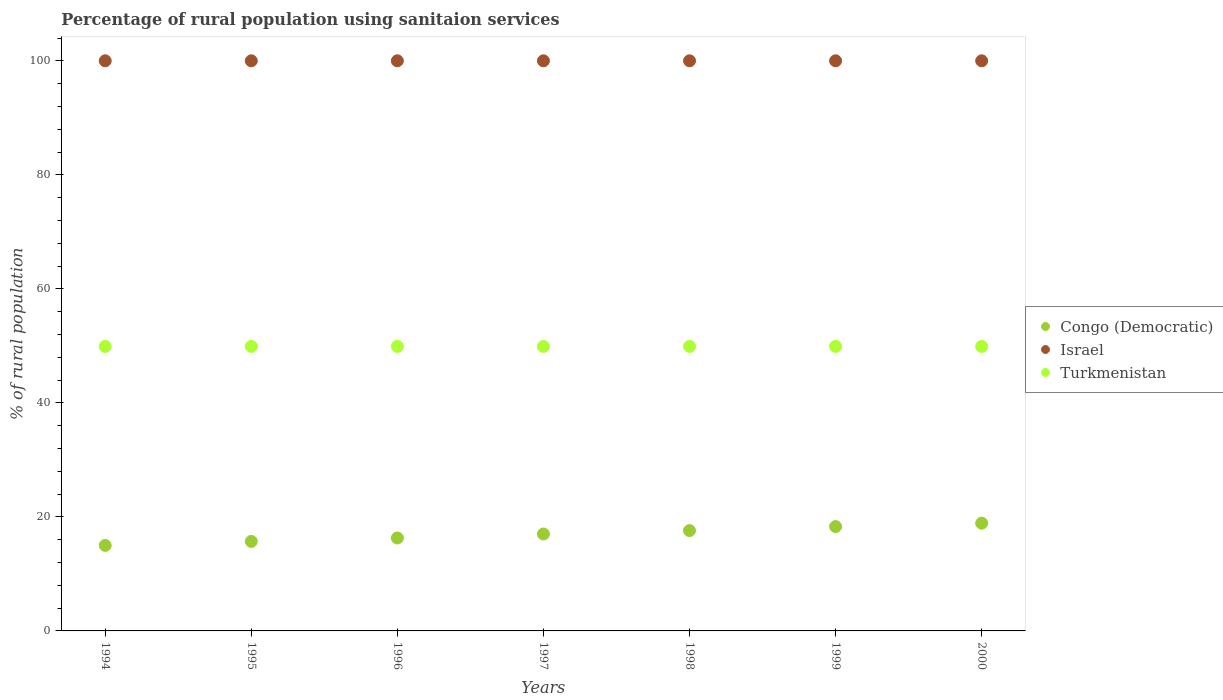How many different coloured dotlines are there?
Your answer should be compact. 3. Is the number of dotlines equal to the number of legend labels?
Your answer should be compact. Yes. What is the percentage of rural population using sanitaion services in Israel in 1994?
Your response must be concise. 100. Across all years, what is the maximum percentage of rural population using sanitaion services in Turkmenistan?
Your answer should be compact. 49.9. Across all years, what is the minimum percentage of rural population using sanitaion services in Turkmenistan?
Your answer should be very brief. 49.9. What is the total percentage of rural population using sanitaion services in Israel in the graph?
Your answer should be very brief. 700. What is the difference between the percentage of rural population using sanitaion services in Israel in 1994 and the percentage of rural population using sanitaion services in Congo (Democratic) in 1995?
Your answer should be compact. 84.3. What is the average percentage of rural population using sanitaion services in Turkmenistan per year?
Your answer should be compact. 49.9. In the year 1995, what is the difference between the percentage of rural population using sanitaion services in Israel and percentage of rural population using sanitaion services in Congo (Democratic)?
Give a very brief answer. 84.3. In how many years, is the percentage of rural population using sanitaion services in Israel greater than 28 %?
Offer a terse response. 7. What is the ratio of the percentage of rural population using sanitaion services in Turkmenistan in 1997 to that in 2000?
Provide a short and direct response. 1. Is the percentage of rural population using sanitaion services in Turkmenistan in 1995 less than that in 1999?
Offer a terse response. No. What is the difference between the highest and the second highest percentage of rural population using sanitaion services in Turkmenistan?
Your answer should be very brief. 0. What is the difference between the highest and the lowest percentage of rural population using sanitaion services in Turkmenistan?
Offer a very short reply. 0. In how many years, is the percentage of rural population using sanitaion services in Congo (Democratic) greater than the average percentage of rural population using sanitaion services in Congo (Democratic) taken over all years?
Give a very brief answer. 4. Is the percentage of rural population using sanitaion services in Congo (Democratic) strictly greater than the percentage of rural population using sanitaion services in Israel over the years?
Provide a short and direct response. No. Are the values on the major ticks of Y-axis written in scientific E-notation?
Your answer should be very brief. No. Does the graph contain any zero values?
Provide a succinct answer. No. How are the legend labels stacked?
Make the answer very short. Vertical. What is the title of the graph?
Ensure brevity in your answer.  Percentage of rural population using sanitaion services. What is the label or title of the Y-axis?
Make the answer very short. % of rural population. What is the % of rural population in Turkmenistan in 1994?
Your answer should be compact. 49.9. What is the % of rural population of Turkmenistan in 1995?
Your answer should be compact. 49.9. What is the % of rural population of Turkmenistan in 1996?
Give a very brief answer. 49.9. What is the % of rural population in Congo (Democratic) in 1997?
Provide a short and direct response. 17. What is the % of rural population of Turkmenistan in 1997?
Provide a short and direct response. 49.9. What is the % of rural population in Congo (Democratic) in 1998?
Your answer should be very brief. 17.6. What is the % of rural population of Israel in 1998?
Give a very brief answer. 100. What is the % of rural population of Turkmenistan in 1998?
Your answer should be compact. 49.9. What is the % of rural population of Congo (Democratic) in 1999?
Provide a succinct answer. 18.3. What is the % of rural population of Turkmenistan in 1999?
Provide a succinct answer. 49.9. What is the % of rural population in Congo (Democratic) in 2000?
Your response must be concise. 18.9. What is the % of rural population of Israel in 2000?
Provide a succinct answer. 100. What is the % of rural population in Turkmenistan in 2000?
Ensure brevity in your answer.  49.9. Across all years, what is the maximum % of rural population in Congo (Democratic)?
Your answer should be compact. 18.9. Across all years, what is the maximum % of rural population in Turkmenistan?
Make the answer very short. 49.9. Across all years, what is the minimum % of rural population in Congo (Democratic)?
Make the answer very short. 15. Across all years, what is the minimum % of rural population of Turkmenistan?
Your answer should be compact. 49.9. What is the total % of rural population in Congo (Democratic) in the graph?
Provide a short and direct response. 118.8. What is the total % of rural population of Israel in the graph?
Keep it short and to the point. 700. What is the total % of rural population in Turkmenistan in the graph?
Offer a very short reply. 349.3. What is the difference between the % of rural population in Congo (Democratic) in 1994 and that in 1995?
Keep it short and to the point. -0.7. What is the difference between the % of rural population in Congo (Democratic) in 1994 and that in 1996?
Offer a very short reply. -1.3. What is the difference between the % of rural population in Israel in 1994 and that in 1996?
Make the answer very short. 0. What is the difference between the % of rural population of Turkmenistan in 1994 and that in 1996?
Your response must be concise. 0. What is the difference between the % of rural population in Turkmenistan in 1994 and that in 1997?
Provide a short and direct response. 0. What is the difference between the % of rural population in Congo (Democratic) in 1994 and that in 1998?
Your answer should be very brief. -2.6. What is the difference between the % of rural population in Israel in 1994 and that in 1998?
Your answer should be compact. 0. What is the difference between the % of rural population of Turkmenistan in 1994 and that in 1998?
Your answer should be very brief. 0. What is the difference between the % of rural population of Congo (Democratic) in 1994 and that in 1999?
Ensure brevity in your answer.  -3.3. What is the difference between the % of rural population of Israel in 1994 and that in 1999?
Offer a terse response. 0. What is the difference between the % of rural population of Congo (Democratic) in 1994 and that in 2000?
Ensure brevity in your answer.  -3.9. What is the difference between the % of rural population in Israel in 1994 and that in 2000?
Give a very brief answer. 0. What is the difference between the % of rural population of Turkmenistan in 1994 and that in 2000?
Keep it short and to the point. 0. What is the difference between the % of rural population in Congo (Democratic) in 1995 and that in 1996?
Your answer should be compact. -0.6. What is the difference between the % of rural population in Israel in 1995 and that in 1996?
Your answer should be compact. 0. What is the difference between the % of rural population of Congo (Democratic) in 1995 and that in 1997?
Give a very brief answer. -1.3. What is the difference between the % of rural population in Turkmenistan in 1995 and that in 1997?
Keep it short and to the point. 0. What is the difference between the % of rural population in Congo (Democratic) in 1995 and that in 1998?
Provide a short and direct response. -1.9. What is the difference between the % of rural population in Turkmenistan in 1995 and that in 1998?
Ensure brevity in your answer.  0. What is the difference between the % of rural population in Congo (Democratic) in 1995 and that in 1999?
Your answer should be very brief. -2.6. What is the difference between the % of rural population of Congo (Democratic) in 1995 and that in 2000?
Your response must be concise. -3.2. What is the difference between the % of rural population of Congo (Democratic) in 1996 and that in 1997?
Ensure brevity in your answer.  -0.7. What is the difference between the % of rural population of Israel in 1996 and that in 1997?
Your response must be concise. 0. What is the difference between the % of rural population of Turkmenistan in 1996 and that in 1998?
Your response must be concise. 0. What is the difference between the % of rural population of Congo (Democratic) in 1996 and that in 1999?
Ensure brevity in your answer.  -2. What is the difference between the % of rural population in Congo (Democratic) in 1996 and that in 2000?
Give a very brief answer. -2.6. What is the difference between the % of rural population of Israel in 1996 and that in 2000?
Your answer should be compact. 0. What is the difference between the % of rural population in Congo (Democratic) in 1997 and that in 1998?
Give a very brief answer. -0.6. What is the difference between the % of rural population of Congo (Democratic) in 1997 and that in 1999?
Offer a very short reply. -1.3. What is the difference between the % of rural population in Turkmenistan in 1997 and that in 1999?
Give a very brief answer. 0. What is the difference between the % of rural population of Congo (Democratic) in 1997 and that in 2000?
Ensure brevity in your answer.  -1.9. What is the difference between the % of rural population in Turkmenistan in 1998 and that in 1999?
Your answer should be compact. 0. What is the difference between the % of rural population of Israel in 1998 and that in 2000?
Give a very brief answer. 0. What is the difference between the % of rural population in Israel in 1999 and that in 2000?
Your answer should be compact. 0. What is the difference between the % of rural population of Congo (Democratic) in 1994 and the % of rural population of Israel in 1995?
Keep it short and to the point. -85. What is the difference between the % of rural population of Congo (Democratic) in 1994 and the % of rural population of Turkmenistan in 1995?
Make the answer very short. -34.9. What is the difference between the % of rural population of Israel in 1994 and the % of rural population of Turkmenistan in 1995?
Your response must be concise. 50.1. What is the difference between the % of rural population in Congo (Democratic) in 1994 and the % of rural population in Israel in 1996?
Provide a short and direct response. -85. What is the difference between the % of rural population of Congo (Democratic) in 1994 and the % of rural population of Turkmenistan in 1996?
Keep it short and to the point. -34.9. What is the difference between the % of rural population in Israel in 1994 and the % of rural population in Turkmenistan in 1996?
Your answer should be very brief. 50.1. What is the difference between the % of rural population of Congo (Democratic) in 1994 and the % of rural population of Israel in 1997?
Your answer should be compact. -85. What is the difference between the % of rural population in Congo (Democratic) in 1994 and the % of rural population in Turkmenistan in 1997?
Offer a very short reply. -34.9. What is the difference between the % of rural population in Israel in 1994 and the % of rural population in Turkmenistan in 1997?
Your answer should be very brief. 50.1. What is the difference between the % of rural population of Congo (Democratic) in 1994 and the % of rural population of Israel in 1998?
Provide a succinct answer. -85. What is the difference between the % of rural population of Congo (Democratic) in 1994 and the % of rural population of Turkmenistan in 1998?
Offer a very short reply. -34.9. What is the difference between the % of rural population in Israel in 1994 and the % of rural population in Turkmenistan in 1998?
Your answer should be very brief. 50.1. What is the difference between the % of rural population of Congo (Democratic) in 1994 and the % of rural population of Israel in 1999?
Make the answer very short. -85. What is the difference between the % of rural population of Congo (Democratic) in 1994 and the % of rural population of Turkmenistan in 1999?
Keep it short and to the point. -34.9. What is the difference between the % of rural population of Israel in 1994 and the % of rural population of Turkmenistan in 1999?
Provide a short and direct response. 50.1. What is the difference between the % of rural population of Congo (Democratic) in 1994 and the % of rural population of Israel in 2000?
Offer a terse response. -85. What is the difference between the % of rural population in Congo (Democratic) in 1994 and the % of rural population in Turkmenistan in 2000?
Give a very brief answer. -34.9. What is the difference between the % of rural population in Israel in 1994 and the % of rural population in Turkmenistan in 2000?
Give a very brief answer. 50.1. What is the difference between the % of rural population in Congo (Democratic) in 1995 and the % of rural population in Israel in 1996?
Provide a succinct answer. -84.3. What is the difference between the % of rural population of Congo (Democratic) in 1995 and the % of rural population of Turkmenistan in 1996?
Offer a very short reply. -34.2. What is the difference between the % of rural population of Israel in 1995 and the % of rural population of Turkmenistan in 1996?
Provide a short and direct response. 50.1. What is the difference between the % of rural population in Congo (Democratic) in 1995 and the % of rural population in Israel in 1997?
Your answer should be very brief. -84.3. What is the difference between the % of rural population in Congo (Democratic) in 1995 and the % of rural population in Turkmenistan in 1997?
Provide a short and direct response. -34.2. What is the difference between the % of rural population of Israel in 1995 and the % of rural population of Turkmenistan in 1997?
Offer a terse response. 50.1. What is the difference between the % of rural population in Congo (Democratic) in 1995 and the % of rural population in Israel in 1998?
Keep it short and to the point. -84.3. What is the difference between the % of rural population of Congo (Democratic) in 1995 and the % of rural population of Turkmenistan in 1998?
Keep it short and to the point. -34.2. What is the difference between the % of rural population in Israel in 1995 and the % of rural population in Turkmenistan in 1998?
Offer a very short reply. 50.1. What is the difference between the % of rural population of Congo (Democratic) in 1995 and the % of rural population of Israel in 1999?
Offer a terse response. -84.3. What is the difference between the % of rural population of Congo (Democratic) in 1995 and the % of rural population of Turkmenistan in 1999?
Provide a short and direct response. -34.2. What is the difference between the % of rural population of Israel in 1995 and the % of rural population of Turkmenistan in 1999?
Keep it short and to the point. 50.1. What is the difference between the % of rural population of Congo (Democratic) in 1995 and the % of rural population of Israel in 2000?
Your answer should be very brief. -84.3. What is the difference between the % of rural population of Congo (Democratic) in 1995 and the % of rural population of Turkmenistan in 2000?
Provide a succinct answer. -34.2. What is the difference between the % of rural population in Israel in 1995 and the % of rural population in Turkmenistan in 2000?
Provide a short and direct response. 50.1. What is the difference between the % of rural population in Congo (Democratic) in 1996 and the % of rural population in Israel in 1997?
Offer a very short reply. -83.7. What is the difference between the % of rural population in Congo (Democratic) in 1996 and the % of rural population in Turkmenistan in 1997?
Your answer should be compact. -33.6. What is the difference between the % of rural population of Israel in 1996 and the % of rural population of Turkmenistan in 1997?
Give a very brief answer. 50.1. What is the difference between the % of rural population in Congo (Democratic) in 1996 and the % of rural population in Israel in 1998?
Make the answer very short. -83.7. What is the difference between the % of rural population of Congo (Democratic) in 1996 and the % of rural population of Turkmenistan in 1998?
Offer a terse response. -33.6. What is the difference between the % of rural population of Israel in 1996 and the % of rural population of Turkmenistan in 1998?
Ensure brevity in your answer.  50.1. What is the difference between the % of rural population of Congo (Democratic) in 1996 and the % of rural population of Israel in 1999?
Your answer should be very brief. -83.7. What is the difference between the % of rural population in Congo (Democratic) in 1996 and the % of rural population in Turkmenistan in 1999?
Your answer should be very brief. -33.6. What is the difference between the % of rural population of Israel in 1996 and the % of rural population of Turkmenistan in 1999?
Ensure brevity in your answer.  50.1. What is the difference between the % of rural population of Congo (Democratic) in 1996 and the % of rural population of Israel in 2000?
Ensure brevity in your answer.  -83.7. What is the difference between the % of rural population in Congo (Democratic) in 1996 and the % of rural population in Turkmenistan in 2000?
Your answer should be very brief. -33.6. What is the difference between the % of rural population in Israel in 1996 and the % of rural population in Turkmenistan in 2000?
Your answer should be compact. 50.1. What is the difference between the % of rural population in Congo (Democratic) in 1997 and the % of rural population in Israel in 1998?
Your response must be concise. -83. What is the difference between the % of rural population of Congo (Democratic) in 1997 and the % of rural population of Turkmenistan in 1998?
Give a very brief answer. -32.9. What is the difference between the % of rural population in Israel in 1997 and the % of rural population in Turkmenistan in 1998?
Provide a short and direct response. 50.1. What is the difference between the % of rural population in Congo (Democratic) in 1997 and the % of rural population in Israel in 1999?
Give a very brief answer. -83. What is the difference between the % of rural population in Congo (Democratic) in 1997 and the % of rural population in Turkmenistan in 1999?
Offer a terse response. -32.9. What is the difference between the % of rural population of Israel in 1997 and the % of rural population of Turkmenistan in 1999?
Your response must be concise. 50.1. What is the difference between the % of rural population in Congo (Democratic) in 1997 and the % of rural population in Israel in 2000?
Your answer should be very brief. -83. What is the difference between the % of rural population of Congo (Democratic) in 1997 and the % of rural population of Turkmenistan in 2000?
Your response must be concise. -32.9. What is the difference between the % of rural population in Israel in 1997 and the % of rural population in Turkmenistan in 2000?
Your answer should be compact. 50.1. What is the difference between the % of rural population in Congo (Democratic) in 1998 and the % of rural population in Israel in 1999?
Offer a terse response. -82.4. What is the difference between the % of rural population in Congo (Democratic) in 1998 and the % of rural population in Turkmenistan in 1999?
Provide a succinct answer. -32.3. What is the difference between the % of rural population of Israel in 1998 and the % of rural population of Turkmenistan in 1999?
Make the answer very short. 50.1. What is the difference between the % of rural population in Congo (Democratic) in 1998 and the % of rural population in Israel in 2000?
Keep it short and to the point. -82.4. What is the difference between the % of rural population of Congo (Democratic) in 1998 and the % of rural population of Turkmenistan in 2000?
Keep it short and to the point. -32.3. What is the difference between the % of rural population of Israel in 1998 and the % of rural population of Turkmenistan in 2000?
Your response must be concise. 50.1. What is the difference between the % of rural population in Congo (Democratic) in 1999 and the % of rural population in Israel in 2000?
Give a very brief answer. -81.7. What is the difference between the % of rural population of Congo (Democratic) in 1999 and the % of rural population of Turkmenistan in 2000?
Give a very brief answer. -31.6. What is the difference between the % of rural population of Israel in 1999 and the % of rural population of Turkmenistan in 2000?
Ensure brevity in your answer.  50.1. What is the average % of rural population in Congo (Democratic) per year?
Make the answer very short. 16.97. What is the average % of rural population of Israel per year?
Your response must be concise. 100. What is the average % of rural population of Turkmenistan per year?
Ensure brevity in your answer.  49.9. In the year 1994, what is the difference between the % of rural population of Congo (Democratic) and % of rural population of Israel?
Give a very brief answer. -85. In the year 1994, what is the difference between the % of rural population in Congo (Democratic) and % of rural population in Turkmenistan?
Make the answer very short. -34.9. In the year 1994, what is the difference between the % of rural population of Israel and % of rural population of Turkmenistan?
Offer a terse response. 50.1. In the year 1995, what is the difference between the % of rural population in Congo (Democratic) and % of rural population in Israel?
Your answer should be compact. -84.3. In the year 1995, what is the difference between the % of rural population in Congo (Democratic) and % of rural population in Turkmenistan?
Offer a very short reply. -34.2. In the year 1995, what is the difference between the % of rural population of Israel and % of rural population of Turkmenistan?
Provide a succinct answer. 50.1. In the year 1996, what is the difference between the % of rural population in Congo (Democratic) and % of rural population in Israel?
Offer a very short reply. -83.7. In the year 1996, what is the difference between the % of rural population of Congo (Democratic) and % of rural population of Turkmenistan?
Keep it short and to the point. -33.6. In the year 1996, what is the difference between the % of rural population in Israel and % of rural population in Turkmenistan?
Provide a short and direct response. 50.1. In the year 1997, what is the difference between the % of rural population of Congo (Democratic) and % of rural population of Israel?
Your answer should be very brief. -83. In the year 1997, what is the difference between the % of rural population of Congo (Democratic) and % of rural population of Turkmenistan?
Your response must be concise. -32.9. In the year 1997, what is the difference between the % of rural population in Israel and % of rural population in Turkmenistan?
Your answer should be very brief. 50.1. In the year 1998, what is the difference between the % of rural population of Congo (Democratic) and % of rural population of Israel?
Ensure brevity in your answer.  -82.4. In the year 1998, what is the difference between the % of rural population in Congo (Democratic) and % of rural population in Turkmenistan?
Offer a very short reply. -32.3. In the year 1998, what is the difference between the % of rural population of Israel and % of rural population of Turkmenistan?
Your response must be concise. 50.1. In the year 1999, what is the difference between the % of rural population in Congo (Democratic) and % of rural population in Israel?
Your answer should be compact. -81.7. In the year 1999, what is the difference between the % of rural population of Congo (Democratic) and % of rural population of Turkmenistan?
Your response must be concise. -31.6. In the year 1999, what is the difference between the % of rural population in Israel and % of rural population in Turkmenistan?
Your response must be concise. 50.1. In the year 2000, what is the difference between the % of rural population in Congo (Democratic) and % of rural population in Israel?
Offer a terse response. -81.1. In the year 2000, what is the difference between the % of rural population of Congo (Democratic) and % of rural population of Turkmenistan?
Ensure brevity in your answer.  -31. In the year 2000, what is the difference between the % of rural population of Israel and % of rural population of Turkmenistan?
Provide a succinct answer. 50.1. What is the ratio of the % of rural population in Congo (Democratic) in 1994 to that in 1995?
Your response must be concise. 0.96. What is the ratio of the % of rural population of Israel in 1994 to that in 1995?
Your response must be concise. 1. What is the ratio of the % of rural population of Turkmenistan in 1994 to that in 1995?
Offer a very short reply. 1. What is the ratio of the % of rural population in Congo (Democratic) in 1994 to that in 1996?
Give a very brief answer. 0.92. What is the ratio of the % of rural population in Turkmenistan in 1994 to that in 1996?
Offer a terse response. 1. What is the ratio of the % of rural population in Congo (Democratic) in 1994 to that in 1997?
Make the answer very short. 0.88. What is the ratio of the % of rural population in Israel in 1994 to that in 1997?
Offer a terse response. 1. What is the ratio of the % of rural population in Turkmenistan in 1994 to that in 1997?
Offer a terse response. 1. What is the ratio of the % of rural population of Congo (Democratic) in 1994 to that in 1998?
Make the answer very short. 0.85. What is the ratio of the % of rural population in Israel in 1994 to that in 1998?
Give a very brief answer. 1. What is the ratio of the % of rural population in Turkmenistan in 1994 to that in 1998?
Your answer should be very brief. 1. What is the ratio of the % of rural population in Congo (Democratic) in 1994 to that in 1999?
Provide a succinct answer. 0.82. What is the ratio of the % of rural population of Turkmenistan in 1994 to that in 1999?
Offer a very short reply. 1. What is the ratio of the % of rural population of Congo (Democratic) in 1994 to that in 2000?
Provide a succinct answer. 0.79. What is the ratio of the % of rural population of Turkmenistan in 1994 to that in 2000?
Offer a very short reply. 1. What is the ratio of the % of rural population of Congo (Democratic) in 1995 to that in 1996?
Your response must be concise. 0.96. What is the ratio of the % of rural population in Congo (Democratic) in 1995 to that in 1997?
Ensure brevity in your answer.  0.92. What is the ratio of the % of rural population of Israel in 1995 to that in 1997?
Offer a very short reply. 1. What is the ratio of the % of rural population in Congo (Democratic) in 1995 to that in 1998?
Give a very brief answer. 0.89. What is the ratio of the % of rural population in Israel in 1995 to that in 1998?
Offer a very short reply. 1. What is the ratio of the % of rural population of Turkmenistan in 1995 to that in 1998?
Provide a succinct answer. 1. What is the ratio of the % of rural population of Congo (Democratic) in 1995 to that in 1999?
Your response must be concise. 0.86. What is the ratio of the % of rural population in Congo (Democratic) in 1995 to that in 2000?
Make the answer very short. 0.83. What is the ratio of the % of rural population in Congo (Democratic) in 1996 to that in 1997?
Provide a succinct answer. 0.96. What is the ratio of the % of rural population in Turkmenistan in 1996 to that in 1997?
Keep it short and to the point. 1. What is the ratio of the % of rural population of Congo (Democratic) in 1996 to that in 1998?
Offer a terse response. 0.93. What is the ratio of the % of rural population of Turkmenistan in 1996 to that in 1998?
Keep it short and to the point. 1. What is the ratio of the % of rural population in Congo (Democratic) in 1996 to that in 1999?
Your answer should be very brief. 0.89. What is the ratio of the % of rural population in Israel in 1996 to that in 1999?
Ensure brevity in your answer.  1. What is the ratio of the % of rural population in Congo (Democratic) in 1996 to that in 2000?
Ensure brevity in your answer.  0.86. What is the ratio of the % of rural population of Congo (Democratic) in 1997 to that in 1998?
Your answer should be very brief. 0.97. What is the ratio of the % of rural population of Turkmenistan in 1997 to that in 1998?
Offer a terse response. 1. What is the ratio of the % of rural population in Congo (Democratic) in 1997 to that in 1999?
Your response must be concise. 0.93. What is the ratio of the % of rural population of Israel in 1997 to that in 1999?
Your answer should be very brief. 1. What is the ratio of the % of rural population in Turkmenistan in 1997 to that in 1999?
Provide a succinct answer. 1. What is the ratio of the % of rural population in Congo (Democratic) in 1997 to that in 2000?
Provide a short and direct response. 0.9. What is the ratio of the % of rural population of Turkmenistan in 1997 to that in 2000?
Make the answer very short. 1. What is the ratio of the % of rural population of Congo (Democratic) in 1998 to that in 1999?
Ensure brevity in your answer.  0.96. What is the ratio of the % of rural population in Israel in 1998 to that in 1999?
Make the answer very short. 1. What is the ratio of the % of rural population of Congo (Democratic) in 1998 to that in 2000?
Provide a short and direct response. 0.93. What is the ratio of the % of rural population of Israel in 1998 to that in 2000?
Provide a succinct answer. 1. What is the ratio of the % of rural population of Turkmenistan in 1998 to that in 2000?
Make the answer very short. 1. What is the ratio of the % of rural population of Congo (Democratic) in 1999 to that in 2000?
Make the answer very short. 0.97. What is the ratio of the % of rural population of Israel in 1999 to that in 2000?
Offer a terse response. 1. What is the ratio of the % of rural population of Turkmenistan in 1999 to that in 2000?
Provide a short and direct response. 1. What is the difference between the highest and the second highest % of rural population of Congo (Democratic)?
Offer a terse response. 0.6. What is the difference between the highest and the second highest % of rural population of Israel?
Your response must be concise. 0. What is the difference between the highest and the lowest % of rural population of Turkmenistan?
Your response must be concise. 0. 